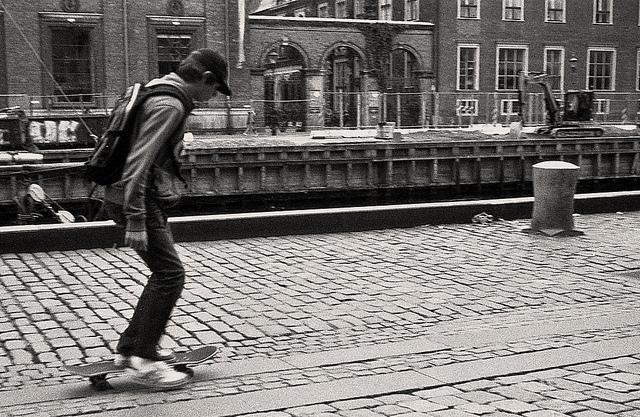How many people in this image are dragging a suitcase behind them?
Give a very brief answer. 0. 